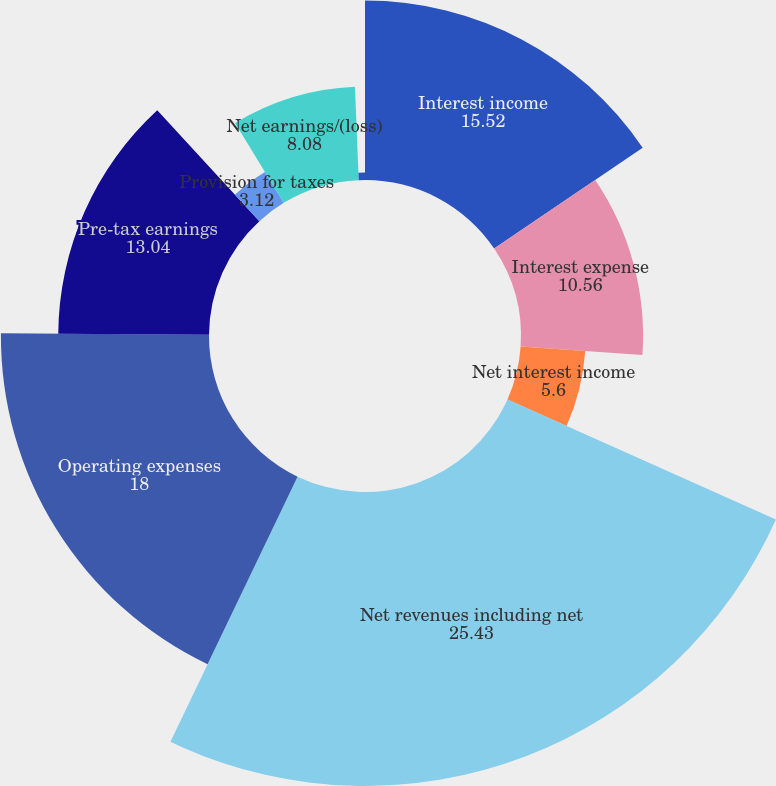Convert chart to OTSL. <chart><loc_0><loc_0><loc_500><loc_500><pie_chart><fcel>Interest income<fcel>Interest expense<fcel>Net interest income<fcel>Net revenues including net<fcel>Operating expenses<fcel>Pre-tax earnings<fcel>Provision for taxes<fcel>Net earnings/(loss)<fcel>Preferred stock dividends<nl><fcel>15.52%<fcel>10.56%<fcel>5.6%<fcel>25.43%<fcel>18.0%<fcel>13.04%<fcel>3.12%<fcel>8.08%<fcel>0.64%<nl></chart> 